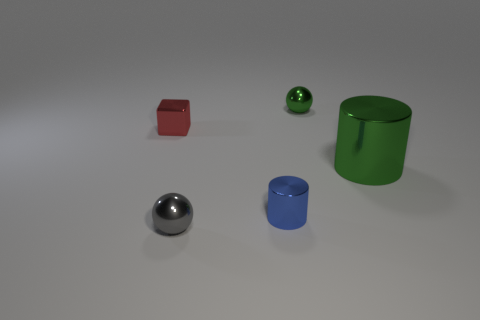Does the metallic block have the same color as the small metallic cylinder? no 